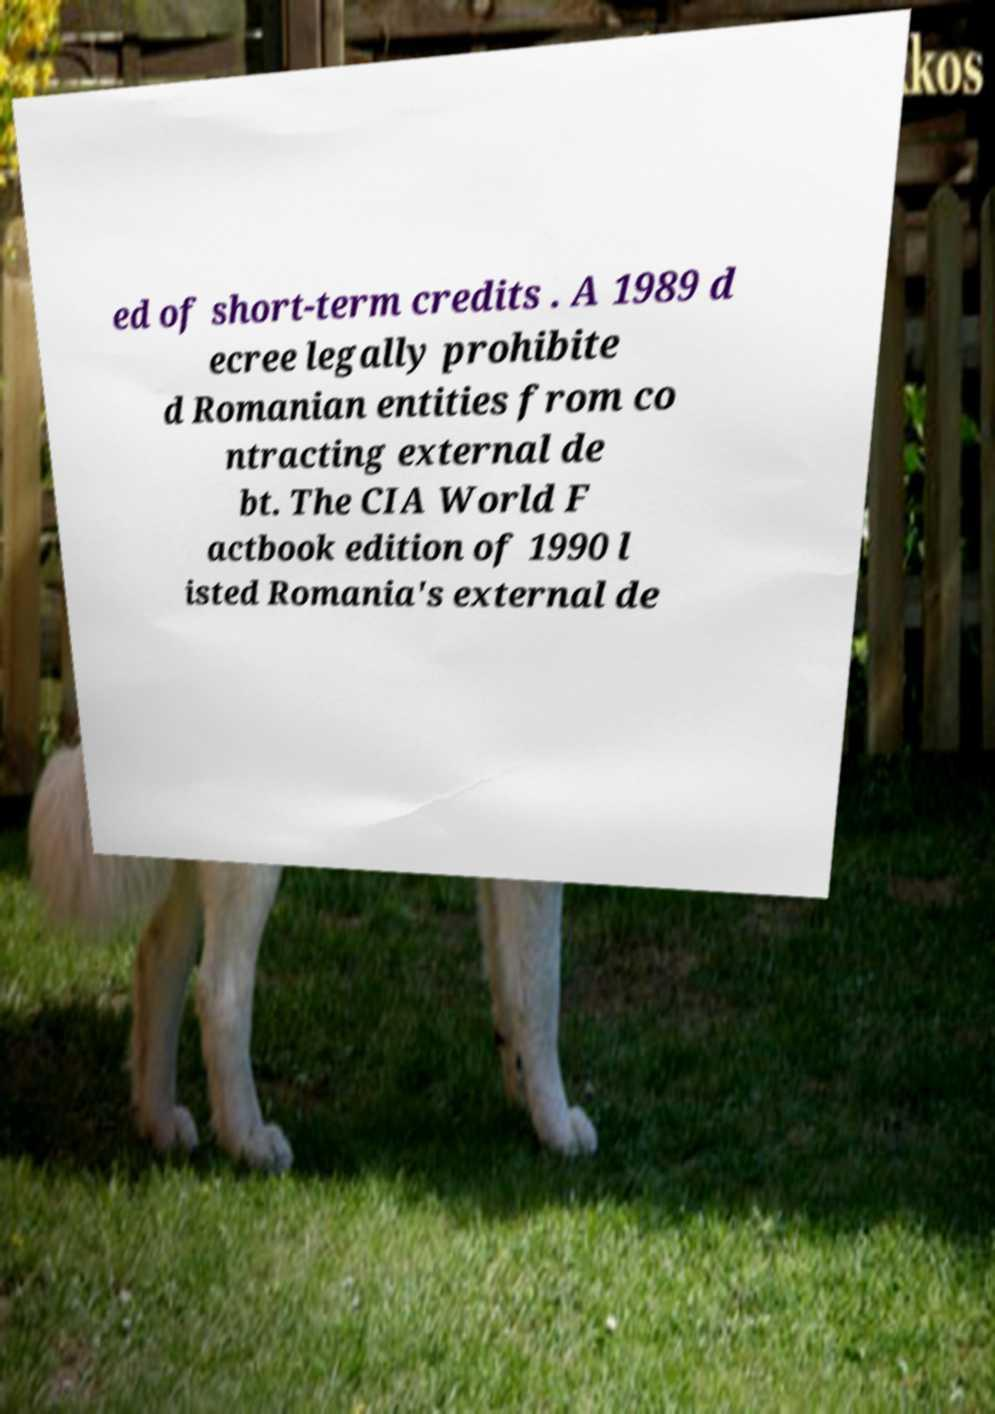There's text embedded in this image that I need extracted. Can you transcribe it verbatim? ed of short-term credits . A 1989 d ecree legally prohibite d Romanian entities from co ntracting external de bt. The CIA World F actbook edition of 1990 l isted Romania's external de 